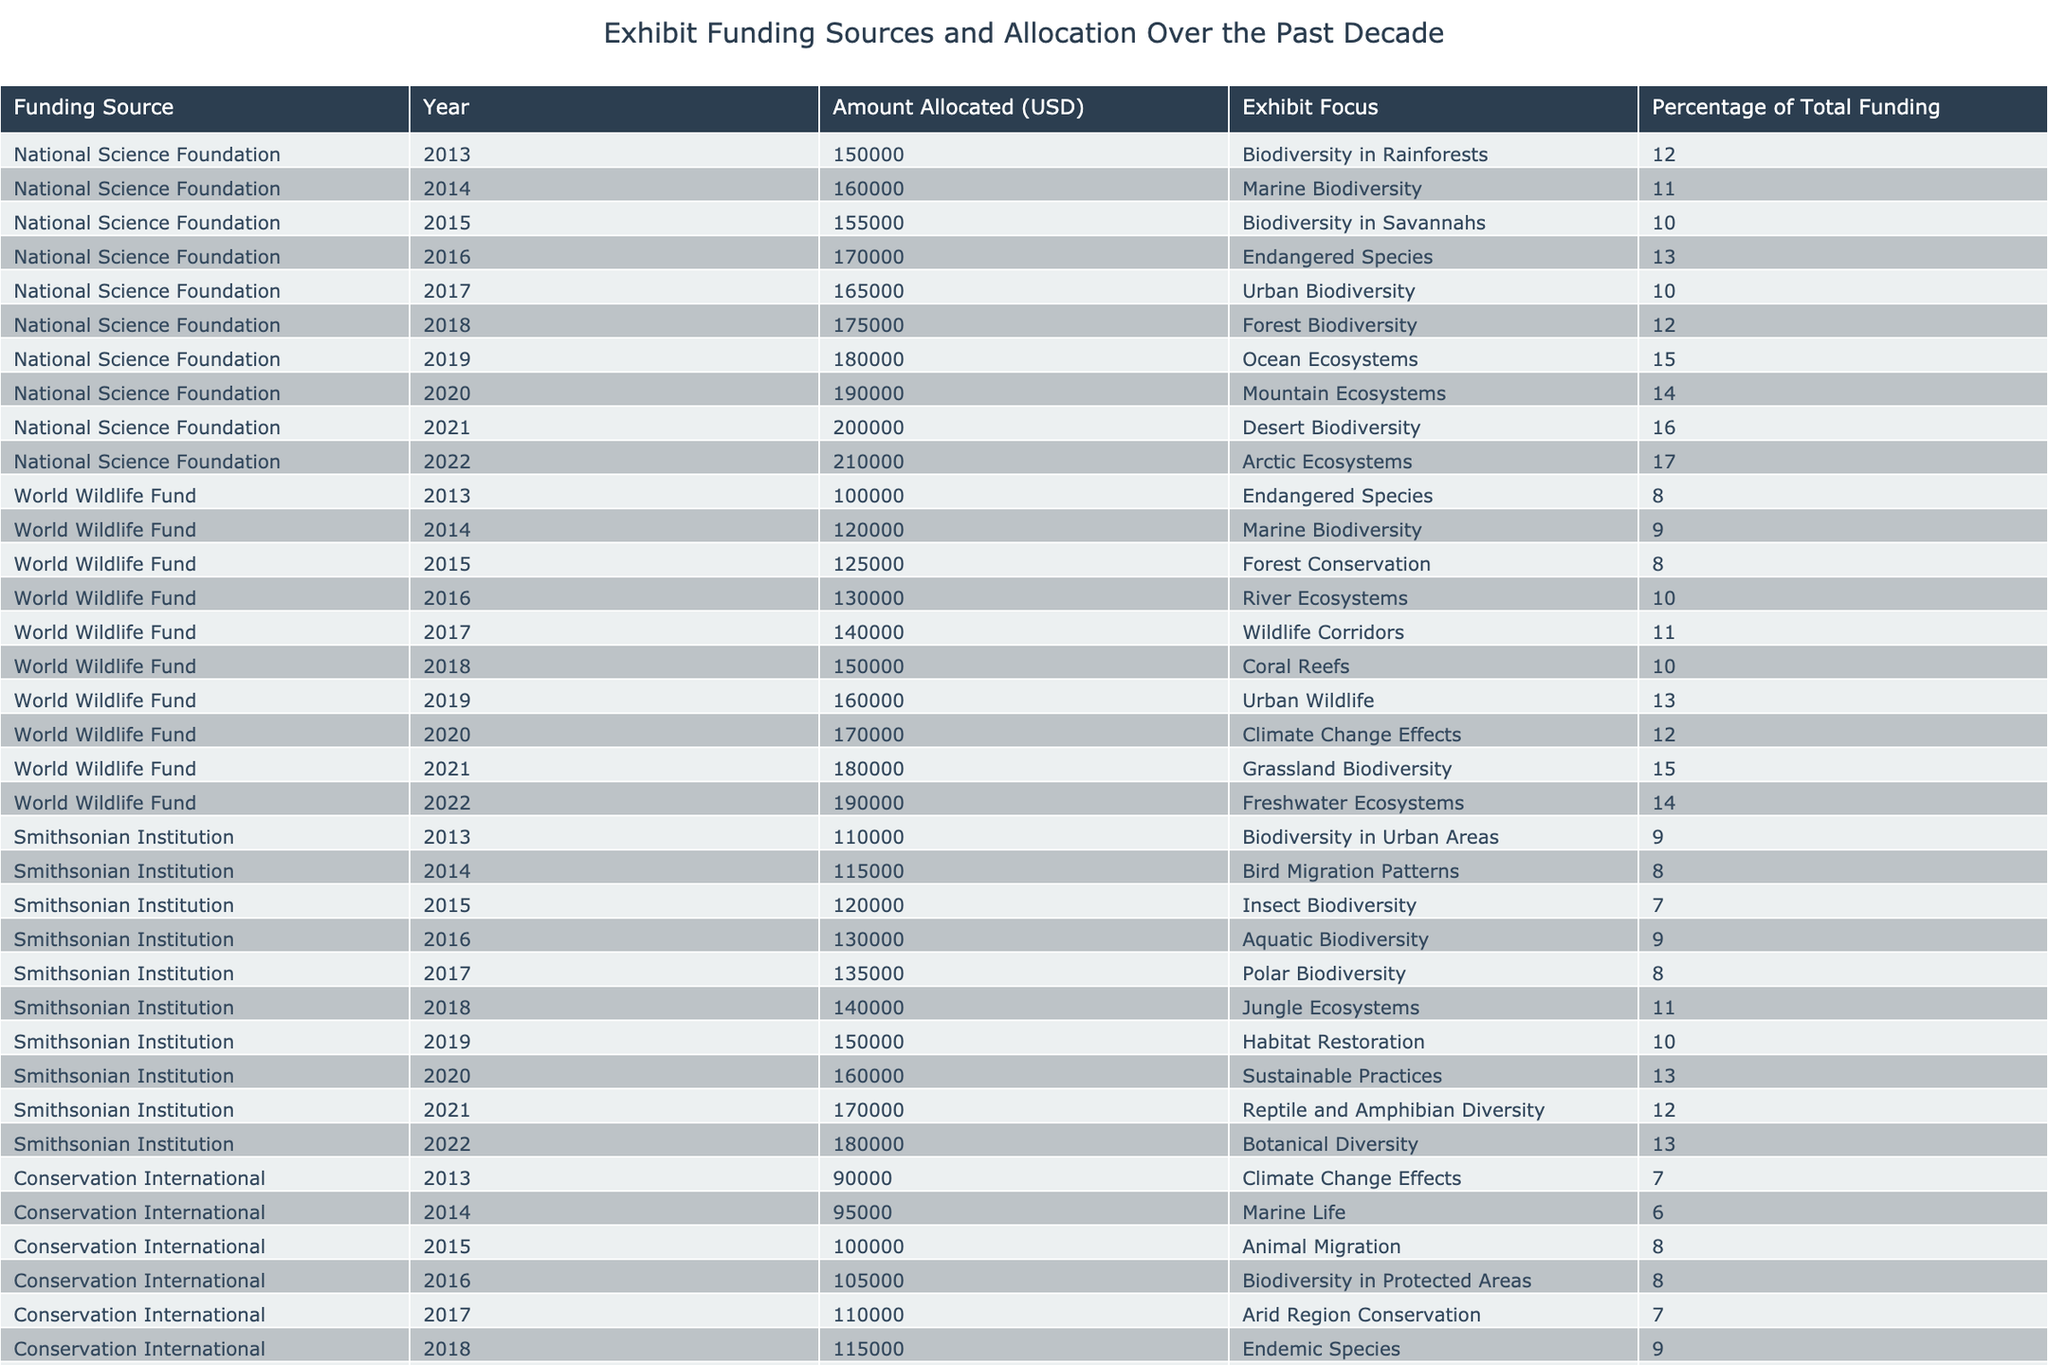What was the total funding allocated by the National Science Foundation in 2020? The National Science Foundation allocated 190000 USD in 2020 for Mountain Ecosystems.
Answer: 190000 USD What percentage of total funding did the World Wildlife Fund allocate for Coral Reefs in 2018? The World Wildlife Fund allocated 150000 USD for Coral Reefs in 2018, which is 10% of their total funding that year.
Answer: 10% Which funding source had the highest allocation in 2022? In 2022, the National Science Foundation allocated 210000 USD, which is the highest allocation compared to other funding sources in the same year.
Answer: National Science Foundation What is the average amount allocated by the Smithsonian Institution over the past decade? The total allocation by the Smithsonian Institution from 2013 to 2022 is 1,330,000 USD (sum of allocations). There are 10 entries, so the average is 1,330,000 / 10 = 133000 USD.
Answer: 133000 USD Did Conservation International allocate any funding for Biodiversity in Rainforests? Conservation International did not allocate any funding for Biodiversity in Rainforests; it is only listed under the National Science Foundation's allocations.
Answer: No What was the combined total funding allocated to Marine Biodiversity by all funding sources in 2014? The National Science Foundation allocated 160000 USD and the World Wildlife Fund allocated 120000 USD in 2014 for Marine Biodiversity. The combined total is 160000 + 120000 = 280000 USD.
Answer: 280000 USD What year saw the lowest funding allocation for Endangered Species across all funding sources? In 2013, the World Wildlife Fund allocated 100000 USD for Endangered Species, which is the lowest compared to 130000 USD in 2016 by the same source.
Answer: 2013 How much total funding was allocated by World Wildlife Fund for Grassland Biodiversity? The World Wildlife Fund allocated 180000 USD for Grassland Biodiversity in 2021, representing their only allocation for this focus area.
Answer: 180000 USD 